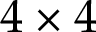Convert formula to latex. <formula><loc_0><loc_0><loc_500><loc_500>4 \times 4</formula> 